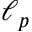<formula> <loc_0><loc_0><loc_500><loc_500>\ell _ { p }</formula> 